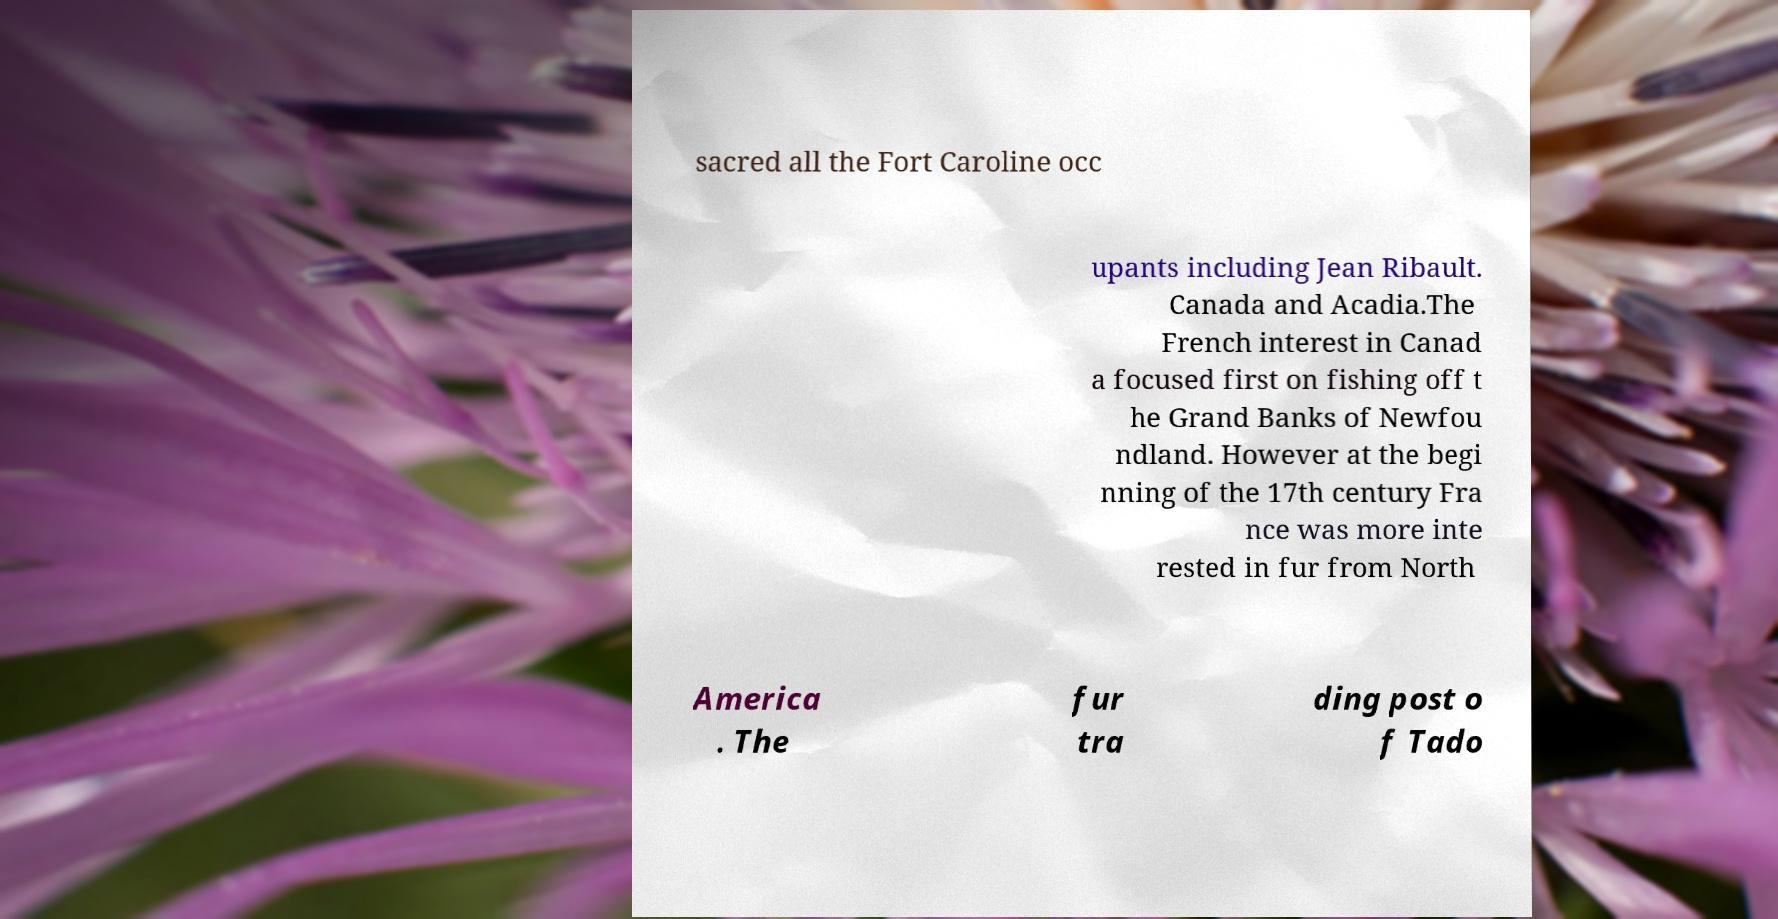Could you extract and type out the text from this image? sacred all the Fort Caroline occ upants including Jean Ribault. Canada and Acadia.The French interest in Canad a focused first on fishing off t he Grand Banks of Newfou ndland. However at the begi nning of the 17th century Fra nce was more inte rested in fur from North America . The fur tra ding post o f Tado 